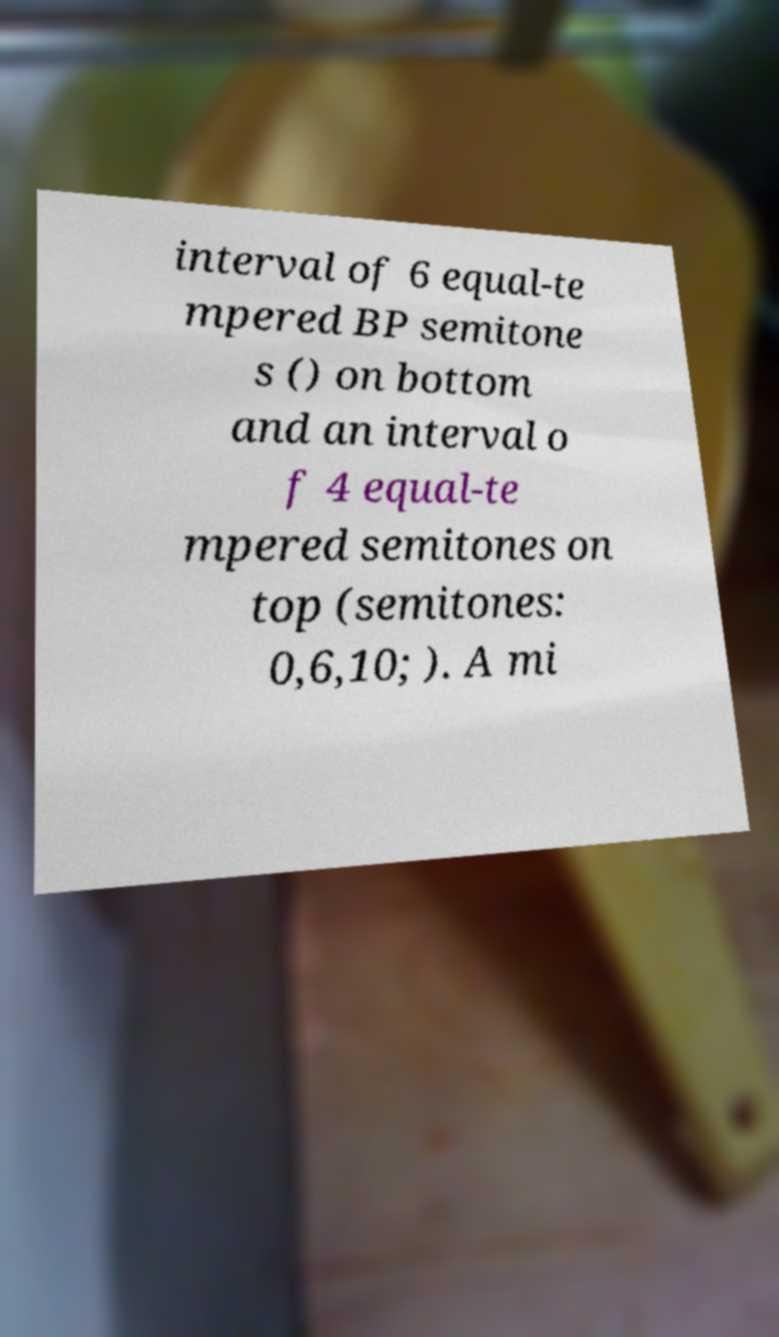Could you extract and type out the text from this image? interval of 6 equal-te mpered BP semitone s () on bottom and an interval o f 4 equal-te mpered semitones on top (semitones: 0,6,10; ). A mi 